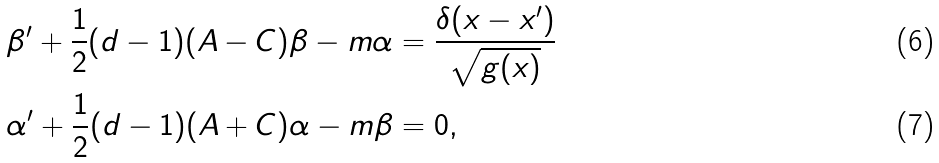Convert formula to latex. <formula><loc_0><loc_0><loc_500><loc_500>\beta ^ { \prime } + \frac { 1 } { 2 } ( d - 1 ) ( A - C ) \beta - m \alpha & = \frac { \delta ( x - x ^ { \prime } ) } { \sqrt { g ( x ) } } \\ \alpha ^ { \prime } + \frac { 1 } { 2 } ( d - 1 ) ( A + C ) \alpha - m \beta & = 0 ,</formula> 